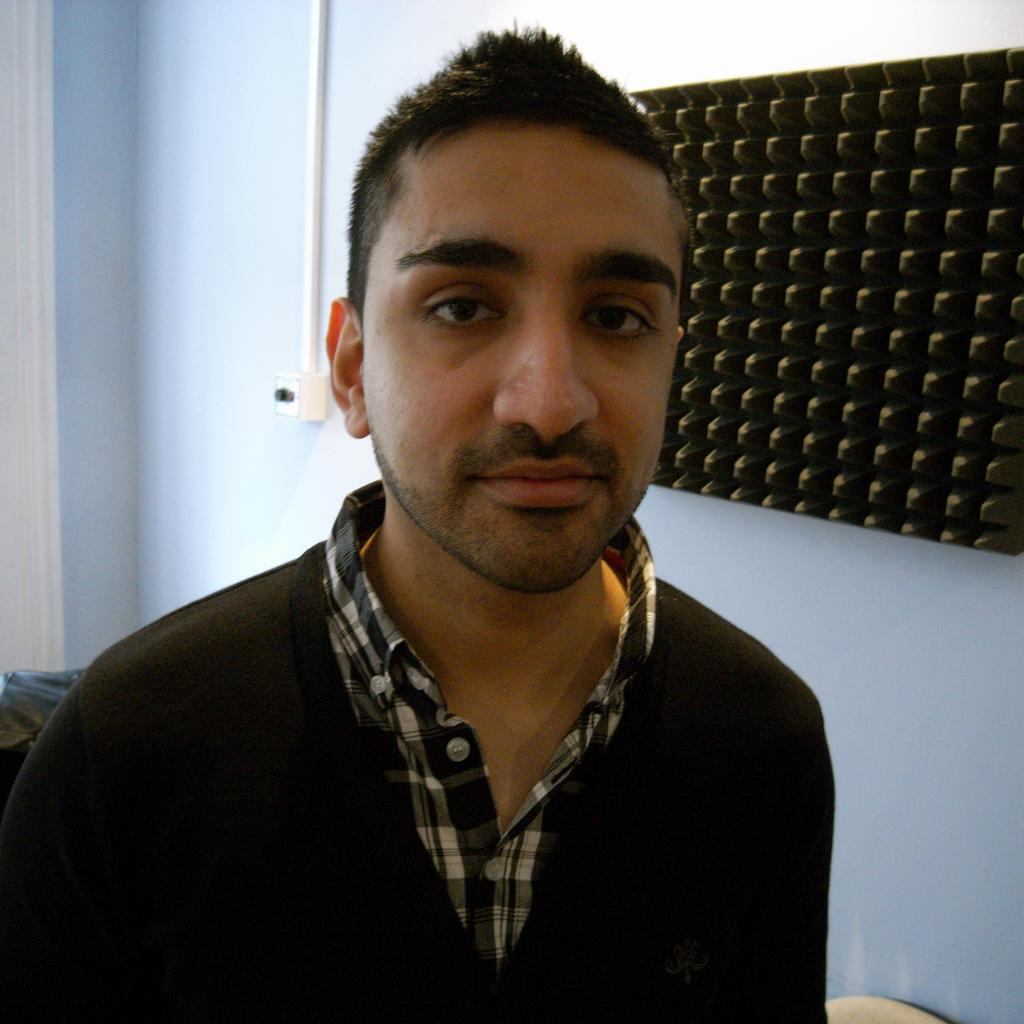What is the main subject in the middle of the image? There is a man in the middle of the image. What is the man wearing in the image? The man is wearing a shirt in the image. What can be seen in the background of the image? There is a wall and a switch board in the background of the image. Are there any other objects visible in the background? Yes, there are objects in the background of the image. What type of paste is being used to stick the cub to the clover in the image? There is no paste, cub, or clover present in the image. 